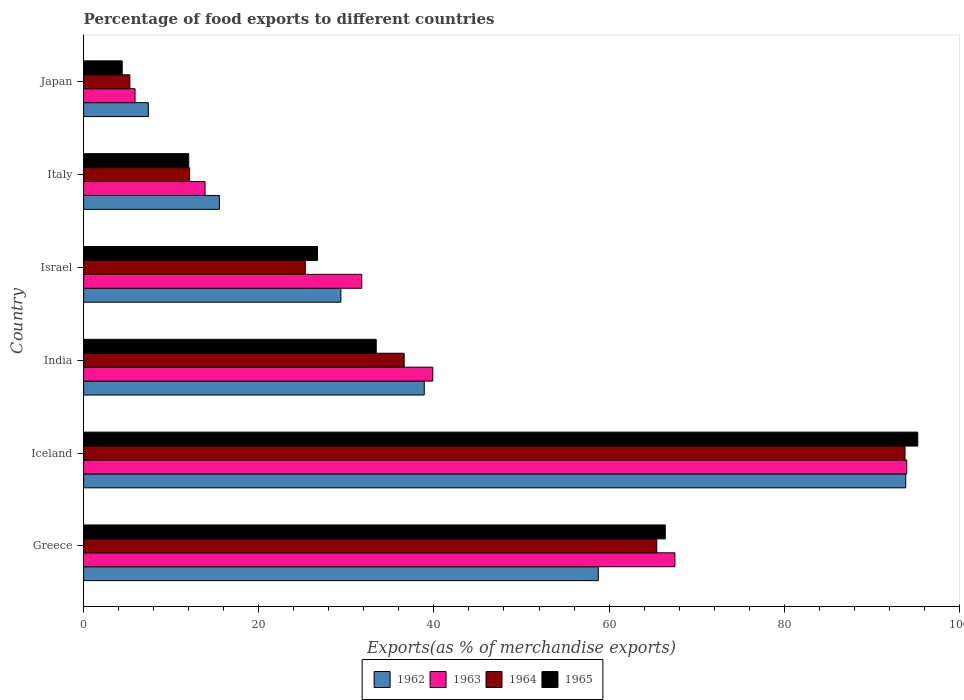How many groups of bars are there?
Keep it short and to the point. 6. Are the number of bars per tick equal to the number of legend labels?
Offer a terse response. Yes. How many bars are there on the 3rd tick from the bottom?
Give a very brief answer. 4. What is the label of the 1st group of bars from the top?
Provide a short and direct response. Japan. In how many cases, is the number of bars for a given country not equal to the number of legend labels?
Offer a terse response. 0. What is the percentage of exports to different countries in 1964 in Greece?
Make the answer very short. 65.45. Across all countries, what is the maximum percentage of exports to different countries in 1964?
Keep it short and to the point. 93.79. Across all countries, what is the minimum percentage of exports to different countries in 1964?
Make the answer very short. 5.28. What is the total percentage of exports to different countries in 1965 in the graph?
Offer a very short reply. 238.2. What is the difference between the percentage of exports to different countries in 1965 in Greece and that in India?
Your answer should be compact. 33.01. What is the difference between the percentage of exports to different countries in 1963 in Greece and the percentage of exports to different countries in 1965 in Iceland?
Ensure brevity in your answer.  -27.73. What is the average percentage of exports to different countries in 1962 per country?
Provide a succinct answer. 40.63. What is the difference between the percentage of exports to different countries in 1964 and percentage of exports to different countries in 1963 in Israel?
Offer a terse response. -6.45. In how many countries, is the percentage of exports to different countries in 1963 greater than 24 %?
Your answer should be compact. 4. What is the ratio of the percentage of exports to different countries in 1965 in Israel to that in Italy?
Provide a short and direct response. 2.23. Is the percentage of exports to different countries in 1965 in Greece less than that in Japan?
Provide a succinct answer. No. What is the difference between the highest and the second highest percentage of exports to different countries in 1962?
Your answer should be compact. 35.1. What is the difference between the highest and the lowest percentage of exports to different countries in 1964?
Provide a succinct answer. 88.51. In how many countries, is the percentage of exports to different countries in 1962 greater than the average percentage of exports to different countries in 1962 taken over all countries?
Give a very brief answer. 2. Is it the case that in every country, the sum of the percentage of exports to different countries in 1962 and percentage of exports to different countries in 1964 is greater than the sum of percentage of exports to different countries in 1963 and percentage of exports to different countries in 1965?
Give a very brief answer. No. How many bars are there?
Provide a short and direct response. 24. Are all the bars in the graph horizontal?
Keep it short and to the point. Yes. What is the difference between two consecutive major ticks on the X-axis?
Your answer should be very brief. 20. Does the graph contain any zero values?
Give a very brief answer. No. Does the graph contain grids?
Provide a succinct answer. No. Where does the legend appear in the graph?
Your answer should be compact. Bottom center. How many legend labels are there?
Ensure brevity in your answer.  4. How are the legend labels stacked?
Give a very brief answer. Horizontal. What is the title of the graph?
Your answer should be very brief. Percentage of food exports to different countries. What is the label or title of the X-axis?
Provide a short and direct response. Exports(as % of merchandise exports). What is the Exports(as % of merchandise exports) of 1962 in Greece?
Offer a terse response. 58.77. What is the Exports(as % of merchandise exports) of 1963 in Greece?
Your answer should be very brief. 67.52. What is the Exports(as % of merchandise exports) in 1964 in Greece?
Make the answer very short. 65.45. What is the Exports(as % of merchandise exports) in 1965 in Greece?
Provide a succinct answer. 66.42. What is the Exports(as % of merchandise exports) in 1962 in Iceland?
Provide a short and direct response. 93.87. What is the Exports(as % of merchandise exports) in 1963 in Iceland?
Give a very brief answer. 93.99. What is the Exports(as % of merchandise exports) in 1964 in Iceland?
Offer a very short reply. 93.79. What is the Exports(as % of merchandise exports) in 1965 in Iceland?
Your answer should be very brief. 95.25. What is the Exports(as % of merchandise exports) of 1962 in India?
Your response must be concise. 38.9. What is the Exports(as % of merchandise exports) in 1963 in India?
Provide a short and direct response. 39.86. What is the Exports(as % of merchandise exports) of 1964 in India?
Your response must be concise. 36.6. What is the Exports(as % of merchandise exports) of 1965 in India?
Make the answer very short. 33.41. What is the Exports(as % of merchandise exports) in 1962 in Israel?
Your response must be concise. 29.37. What is the Exports(as % of merchandise exports) in 1963 in Israel?
Your answer should be compact. 31.76. What is the Exports(as % of merchandise exports) in 1964 in Israel?
Your answer should be compact. 25.31. What is the Exports(as % of merchandise exports) in 1965 in Israel?
Provide a succinct answer. 26.71. What is the Exports(as % of merchandise exports) of 1962 in Italy?
Ensure brevity in your answer.  15.5. What is the Exports(as % of merchandise exports) in 1963 in Italy?
Ensure brevity in your answer.  13.86. What is the Exports(as % of merchandise exports) in 1964 in Italy?
Ensure brevity in your answer.  12.1. What is the Exports(as % of merchandise exports) of 1965 in Italy?
Keep it short and to the point. 12. What is the Exports(as % of merchandise exports) in 1962 in Japan?
Your answer should be compact. 7.39. What is the Exports(as % of merchandise exports) in 1963 in Japan?
Offer a terse response. 5.87. What is the Exports(as % of merchandise exports) of 1964 in Japan?
Keep it short and to the point. 5.28. What is the Exports(as % of merchandise exports) of 1965 in Japan?
Your answer should be very brief. 4.41. Across all countries, what is the maximum Exports(as % of merchandise exports) of 1962?
Make the answer very short. 93.87. Across all countries, what is the maximum Exports(as % of merchandise exports) of 1963?
Offer a terse response. 93.99. Across all countries, what is the maximum Exports(as % of merchandise exports) in 1964?
Provide a short and direct response. 93.79. Across all countries, what is the maximum Exports(as % of merchandise exports) in 1965?
Offer a terse response. 95.25. Across all countries, what is the minimum Exports(as % of merchandise exports) in 1962?
Offer a terse response. 7.39. Across all countries, what is the minimum Exports(as % of merchandise exports) of 1963?
Make the answer very short. 5.87. Across all countries, what is the minimum Exports(as % of merchandise exports) in 1964?
Offer a terse response. 5.28. Across all countries, what is the minimum Exports(as % of merchandise exports) of 1965?
Ensure brevity in your answer.  4.41. What is the total Exports(as % of merchandise exports) in 1962 in the graph?
Make the answer very short. 243.81. What is the total Exports(as % of merchandise exports) of 1963 in the graph?
Your answer should be very brief. 252.87. What is the total Exports(as % of merchandise exports) in 1964 in the graph?
Your answer should be very brief. 238.53. What is the total Exports(as % of merchandise exports) in 1965 in the graph?
Your answer should be compact. 238.2. What is the difference between the Exports(as % of merchandise exports) of 1962 in Greece and that in Iceland?
Ensure brevity in your answer.  -35.1. What is the difference between the Exports(as % of merchandise exports) in 1963 in Greece and that in Iceland?
Keep it short and to the point. -26.47. What is the difference between the Exports(as % of merchandise exports) of 1964 in Greece and that in Iceland?
Keep it short and to the point. -28.35. What is the difference between the Exports(as % of merchandise exports) of 1965 in Greece and that in Iceland?
Provide a succinct answer. -28.83. What is the difference between the Exports(as % of merchandise exports) of 1962 in Greece and that in India?
Make the answer very short. 19.87. What is the difference between the Exports(as % of merchandise exports) in 1963 in Greece and that in India?
Your answer should be very brief. 27.65. What is the difference between the Exports(as % of merchandise exports) of 1964 in Greece and that in India?
Give a very brief answer. 28.84. What is the difference between the Exports(as % of merchandise exports) of 1965 in Greece and that in India?
Keep it short and to the point. 33.01. What is the difference between the Exports(as % of merchandise exports) in 1962 in Greece and that in Israel?
Your answer should be compact. 29.4. What is the difference between the Exports(as % of merchandise exports) of 1963 in Greece and that in Israel?
Keep it short and to the point. 35.76. What is the difference between the Exports(as % of merchandise exports) of 1964 in Greece and that in Israel?
Give a very brief answer. 40.14. What is the difference between the Exports(as % of merchandise exports) of 1965 in Greece and that in Israel?
Ensure brevity in your answer.  39.71. What is the difference between the Exports(as % of merchandise exports) in 1962 in Greece and that in Italy?
Give a very brief answer. 43.27. What is the difference between the Exports(as % of merchandise exports) of 1963 in Greece and that in Italy?
Your answer should be compact. 53.65. What is the difference between the Exports(as % of merchandise exports) of 1964 in Greece and that in Italy?
Provide a succinct answer. 53.35. What is the difference between the Exports(as % of merchandise exports) of 1965 in Greece and that in Italy?
Keep it short and to the point. 54.42. What is the difference between the Exports(as % of merchandise exports) in 1962 in Greece and that in Japan?
Give a very brief answer. 51.38. What is the difference between the Exports(as % of merchandise exports) in 1963 in Greece and that in Japan?
Provide a short and direct response. 61.65. What is the difference between the Exports(as % of merchandise exports) in 1964 in Greece and that in Japan?
Your response must be concise. 60.17. What is the difference between the Exports(as % of merchandise exports) in 1965 in Greece and that in Japan?
Ensure brevity in your answer.  62.01. What is the difference between the Exports(as % of merchandise exports) of 1962 in Iceland and that in India?
Offer a very short reply. 54.98. What is the difference between the Exports(as % of merchandise exports) in 1963 in Iceland and that in India?
Your answer should be compact. 54.13. What is the difference between the Exports(as % of merchandise exports) in 1964 in Iceland and that in India?
Offer a very short reply. 57.19. What is the difference between the Exports(as % of merchandise exports) in 1965 in Iceland and that in India?
Make the answer very short. 61.84. What is the difference between the Exports(as % of merchandise exports) in 1962 in Iceland and that in Israel?
Keep it short and to the point. 64.5. What is the difference between the Exports(as % of merchandise exports) of 1963 in Iceland and that in Israel?
Your response must be concise. 62.23. What is the difference between the Exports(as % of merchandise exports) of 1964 in Iceland and that in Israel?
Your answer should be compact. 68.48. What is the difference between the Exports(as % of merchandise exports) in 1965 in Iceland and that in Israel?
Your answer should be very brief. 68.54. What is the difference between the Exports(as % of merchandise exports) of 1962 in Iceland and that in Italy?
Your response must be concise. 78.37. What is the difference between the Exports(as % of merchandise exports) of 1963 in Iceland and that in Italy?
Keep it short and to the point. 80.13. What is the difference between the Exports(as % of merchandise exports) of 1964 in Iceland and that in Italy?
Offer a very short reply. 81.69. What is the difference between the Exports(as % of merchandise exports) in 1965 in Iceland and that in Italy?
Your answer should be very brief. 83.25. What is the difference between the Exports(as % of merchandise exports) in 1962 in Iceland and that in Japan?
Give a very brief answer. 86.49. What is the difference between the Exports(as % of merchandise exports) of 1963 in Iceland and that in Japan?
Ensure brevity in your answer.  88.12. What is the difference between the Exports(as % of merchandise exports) of 1964 in Iceland and that in Japan?
Provide a short and direct response. 88.51. What is the difference between the Exports(as % of merchandise exports) in 1965 in Iceland and that in Japan?
Your answer should be very brief. 90.84. What is the difference between the Exports(as % of merchandise exports) in 1962 in India and that in Israel?
Your answer should be very brief. 9.52. What is the difference between the Exports(as % of merchandise exports) of 1963 in India and that in Israel?
Make the answer very short. 8.1. What is the difference between the Exports(as % of merchandise exports) in 1964 in India and that in Israel?
Offer a very short reply. 11.29. What is the difference between the Exports(as % of merchandise exports) in 1965 in India and that in Israel?
Keep it short and to the point. 6.71. What is the difference between the Exports(as % of merchandise exports) of 1962 in India and that in Italy?
Your response must be concise. 23.39. What is the difference between the Exports(as % of merchandise exports) in 1963 in India and that in Italy?
Offer a very short reply. 26. What is the difference between the Exports(as % of merchandise exports) of 1964 in India and that in Italy?
Your response must be concise. 24.5. What is the difference between the Exports(as % of merchandise exports) in 1965 in India and that in Italy?
Ensure brevity in your answer.  21.41. What is the difference between the Exports(as % of merchandise exports) of 1962 in India and that in Japan?
Offer a very short reply. 31.51. What is the difference between the Exports(as % of merchandise exports) of 1963 in India and that in Japan?
Provide a succinct answer. 34. What is the difference between the Exports(as % of merchandise exports) of 1964 in India and that in Japan?
Give a very brief answer. 31.32. What is the difference between the Exports(as % of merchandise exports) of 1965 in India and that in Japan?
Provide a short and direct response. 29.01. What is the difference between the Exports(as % of merchandise exports) of 1962 in Israel and that in Italy?
Your answer should be compact. 13.87. What is the difference between the Exports(as % of merchandise exports) in 1963 in Israel and that in Italy?
Keep it short and to the point. 17.9. What is the difference between the Exports(as % of merchandise exports) in 1964 in Israel and that in Italy?
Offer a very short reply. 13.21. What is the difference between the Exports(as % of merchandise exports) in 1965 in Israel and that in Italy?
Your answer should be compact. 14.71. What is the difference between the Exports(as % of merchandise exports) in 1962 in Israel and that in Japan?
Offer a very short reply. 21.98. What is the difference between the Exports(as % of merchandise exports) of 1963 in Israel and that in Japan?
Ensure brevity in your answer.  25.89. What is the difference between the Exports(as % of merchandise exports) in 1964 in Israel and that in Japan?
Offer a very short reply. 20.03. What is the difference between the Exports(as % of merchandise exports) of 1965 in Israel and that in Japan?
Give a very brief answer. 22.3. What is the difference between the Exports(as % of merchandise exports) in 1962 in Italy and that in Japan?
Keep it short and to the point. 8.11. What is the difference between the Exports(as % of merchandise exports) of 1963 in Italy and that in Japan?
Offer a very short reply. 8. What is the difference between the Exports(as % of merchandise exports) in 1964 in Italy and that in Japan?
Your answer should be compact. 6.82. What is the difference between the Exports(as % of merchandise exports) in 1965 in Italy and that in Japan?
Your answer should be compact. 7.59. What is the difference between the Exports(as % of merchandise exports) in 1962 in Greece and the Exports(as % of merchandise exports) in 1963 in Iceland?
Keep it short and to the point. -35.22. What is the difference between the Exports(as % of merchandise exports) of 1962 in Greece and the Exports(as % of merchandise exports) of 1964 in Iceland?
Your answer should be very brief. -35.02. What is the difference between the Exports(as % of merchandise exports) in 1962 in Greece and the Exports(as % of merchandise exports) in 1965 in Iceland?
Give a very brief answer. -36.48. What is the difference between the Exports(as % of merchandise exports) in 1963 in Greece and the Exports(as % of merchandise exports) in 1964 in Iceland?
Ensure brevity in your answer.  -26.27. What is the difference between the Exports(as % of merchandise exports) in 1963 in Greece and the Exports(as % of merchandise exports) in 1965 in Iceland?
Make the answer very short. -27.73. What is the difference between the Exports(as % of merchandise exports) in 1964 in Greece and the Exports(as % of merchandise exports) in 1965 in Iceland?
Provide a short and direct response. -29.8. What is the difference between the Exports(as % of merchandise exports) of 1962 in Greece and the Exports(as % of merchandise exports) of 1963 in India?
Offer a terse response. 18.91. What is the difference between the Exports(as % of merchandise exports) in 1962 in Greece and the Exports(as % of merchandise exports) in 1964 in India?
Offer a terse response. 22.17. What is the difference between the Exports(as % of merchandise exports) in 1962 in Greece and the Exports(as % of merchandise exports) in 1965 in India?
Ensure brevity in your answer.  25.36. What is the difference between the Exports(as % of merchandise exports) in 1963 in Greece and the Exports(as % of merchandise exports) in 1964 in India?
Offer a very short reply. 30.92. What is the difference between the Exports(as % of merchandise exports) of 1963 in Greece and the Exports(as % of merchandise exports) of 1965 in India?
Keep it short and to the point. 34.1. What is the difference between the Exports(as % of merchandise exports) of 1964 in Greece and the Exports(as % of merchandise exports) of 1965 in India?
Make the answer very short. 32.03. What is the difference between the Exports(as % of merchandise exports) of 1962 in Greece and the Exports(as % of merchandise exports) of 1963 in Israel?
Your response must be concise. 27.01. What is the difference between the Exports(as % of merchandise exports) of 1962 in Greece and the Exports(as % of merchandise exports) of 1964 in Israel?
Make the answer very short. 33.46. What is the difference between the Exports(as % of merchandise exports) of 1962 in Greece and the Exports(as % of merchandise exports) of 1965 in Israel?
Make the answer very short. 32.06. What is the difference between the Exports(as % of merchandise exports) in 1963 in Greece and the Exports(as % of merchandise exports) in 1964 in Israel?
Ensure brevity in your answer.  42.21. What is the difference between the Exports(as % of merchandise exports) of 1963 in Greece and the Exports(as % of merchandise exports) of 1965 in Israel?
Your response must be concise. 40.81. What is the difference between the Exports(as % of merchandise exports) of 1964 in Greece and the Exports(as % of merchandise exports) of 1965 in Israel?
Your response must be concise. 38.74. What is the difference between the Exports(as % of merchandise exports) in 1962 in Greece and the Exports(as % of merchandise exports) in 1963 in Italy?
Provide a succinct answer. 44.91. What is the difference between the Exports(as % of merchandise exports) in 1962 in Greece and the Exports(as % of merchandise exports) in 1964 in Italy?
Your response must be concise. 46.67. What is the difference between the Exports(as % of merchandise exports) of 1962 in Greece and the Exports(as % of merchandise exports) of 1965 in Italy?
Your answer should be compact. 46.77. What is the difference between the Exports(as % of merchandise exports) of 1963 in Greece and the Exports(as % of merchandise exports) of 1964 in Italy?
Offer a terse response. 55.42. What is the difference between the Exports(as % of merchandise exports) of 1963 in Greece and the Exports(as % of merchandise exports) of 1965 in Italy?
Keep it short and to the point. 55.52. What is the difference between the Exports(as % of merchandise exports) of 1964 in Greece and the Exports(as % of merchandise exports) of 1965 in Italy?
Offer a terse response. 53.45. What is the difference between the Exports(as % of merchandise exports) in 1962 in Greece and the Exports(as % of merchandise exports) in 1963 in Japan?
Your answer should be very brief. 52.9. What is the difference between the Exports(as % of merchandise exports) in 1962 in Greece and the Exports(as % of merchandise exports) in 1964 in Japan?
Make the answer very short. 53.49. What is the difference between the Exports(as % of merchandise exports) in 1962 in Greece and the Exports(as % of merchandise exports) in 1965 in Japan?
Make the answer very short. 54.36. What is the difference between the Exports(as % of merchandise exports) in 1963 in Greece and the Exports(as % of merchandise exports) in 1964 in Japan?
Keep it short and to the point. 62.24. What is the difference between the Exports(as % of merchandise exports) of 1963 in Greece and the Exports(as % of merchandise exports) of 1965 in Japan?
Provide a short and direct response. 63.11. What is the difference between the Exports(as % of merchandise exports) of 1964 in Greece and the Exports(as % of merchandise exports) of 1965 in Japan?
Provide a short and direct response. 61.04. What is the difference between the Exports(as % of merchandise exports) in 1962 in Iceland and the Exports(as % of merchandise exports) in 1963 in India?
Make the answer very short. 54.01. What is the difference between the Exports(as % of merchandise exports) of 1962 in Iceland and the Exports(as % of merchandise exports) of 1964 in India?
Offer a very short reply. 57.27. What is the difference between the Exports(as % of merchandise exports) in 1962 in Iceland and the Exports(as % of merchandise exports) in 1965 in India?
Provide a succinct answer. 60.46. What is the difference between the Exports(as % of merchandise exports) of 1963 in Iceland and the Exports(as % of merchandise exports) of 1964 in India?
Offer a terse response. 57.39. What is the difference between the Exports(as % of merchandise exports) in 1963 in Iceland and the Exports(as % of merchandise exports) in 1965 in India?
Your response must be concise. 60.58. What is the difference between the Exports(as % of merchandise exports) in 1964 in Iceland and the Exports(as % of merchandise exports) in 1965 in India?
Offer a very short reply. 60.38. What is the difference between the Exports(as % of merchandise exports) of 1962 in Iceland and the Exports(as % of merchandise exports) of 1963 in Israel?
Provide a short and direct response. 62.11. What is the difference between the Exports(as % of merchandise exports) in 1962 in Iceland and the Exports(as % of merchandise exports) in 1964 in Israel?
Offer a very short reply. 68.57. What is the difference between the Exports(as % of merchandise exports) of 1962 in Iceland and the Exports(as % of merchandise exports) of 1965 in Israel?
Ensure brevity in your answer.  67.17. What is the difference between the Exports(as % of merchandise exports) in 1963 in Iceland and the Exports(as % of merchandise exports) in 1964 in Israel?
Offer a very short reply. 68.68. What is the difference between the Exports(as % of merchandise exports) of 1963 in Iceland and the Exports(as % of merchandise exports) of 1965 in Israel?
Your answer should be compact. 67.28. What is the difference between the Exports(as % of merchandise exports) of 1964 in Iceland and the Exports(as % of merchandise exports) of 1965 in Israel?
Offer a terse response. 67.08. What is the difference between the Exports(as % of merchandise exports) in 1962 in Iceland and the Exports(as % of merchandise exports) in 1963 in Italy?
Make the answer very short. 80.01. What is the difference between the Exports(as % of merchandise exports) of 1962 in Iceland and the Exports(as % of merchandise exports) of 1964 in Italy?
Give a very brief answer. 81.78. What is the difference between the Exports(as % of merchandise exports) of 1962 in Iceland and the Exports(as % of merchandise exports) of 1965 in Italy?
Offer a very short reply. 81.88. What is the difference between the Exports(as % of merchandise exports) of 1963 in Iceland and the Exports(as % of merchandise exports) of 1964 in Italy?
Your response must be concise. 81.89. What is the difference between the Exports(as % of merchandise exports) of 1963 in Iceland and the Exports(as % of merchandise exports) of 1965 in Italy?
Keep it short and to the point. 81.99. What is the difference between the Exports(as % of merchandise exports) in 1964 in Iceland and the Exports(as % of merchandise exports) in 1965 in Italy?
Make the answer very short. 81.79. What is the difference between the Exports(as % of merchandise exports) of 1962 in Iceland and the Exports(as % of merchandise exports) of 1963 in Japan?
Offer a very short reply. 88.01. What is the difference between the Exports(as % of merchandise exports) of 1962 in Iceland and the Exports(as % of merchandise exports) of 1964 in Japan?
Keep it short and to the point. 88.6. What is the difference between the Exports(as % of merchandise exports) in 1962 in Iceland and the Exports(as % of merchandise exports) in 1965 in Japan?
Your answer should be compact. 89.47. What is the difference between the Exports(as % of merchandise exports) in 1963 in Iceland and the Exports(as % of merchandise exports) in 1964 in Japan?
Provide a succinct answer. 88.71. What is the difference between the Exports(as % of merchandise exports) in 1963 in Iceland and the Exports(as % of merchandise exports) in 1965 in Japan?
Ensure brevity in your answer.  89.58. What is the difference between the Exports(as % of merchandise exports) of 1964 in Iceland and the Exports(as % of merchandise exports) of 1965 in Japan?
Provide a short and direct response. 89.38. What is the difference between the Exports(as % of merchandise exports) in 1962 in India and the Exports(as % of merchandise exports) in 1963 in Israel?
Ensure brevity in your answer.  7.14. What is the difference between the Exports(as % of merchandise exports) of 1962 in India and the Exports(as % of merchandise exports) of 1964 in Israel?
Your answer should be compact. 13.59. What is the difference between the Exports(as % of merchandise exports) in 1962 in India and the Exports(as % of merchandise exports) in 1965 in Israel?
Your answer should be compact. 12.19. What is the difference between the Exports(as % of merchandise exports) in 1963 in India and the Exports(as % of merchandise exports) in 1964 in Israel?
Ensure brevity in your answer.  14.56. What is the difference between the Exports(as % of merchandise exports) of 1963 in India and the Exports(as % of merchandise exports) of 1965 in Israel?
Your response must be concise. 13.16. What is the difference between the Exports(as % of merchandise exports) in 1964 in India and the Exports(as % of merchandise exports) in 1965 in Israel?
Your response must be concise. 9.89. What is the difference between the Exports(as % of merchandise exports) in 1962 in India and the Exports(as % of merchandise exports) in 1963 in Italy?
Offer a very short reply. 25.03. What is the difference between the Exports(as % of merchandise exports) of 1962 in India and the Exports(as % of merchandise exports) of 1964 in Italy?
Offer a terse response. 26.8. What is the difference between the Exports(as % of merchandise exports) in 1962 in India and the Exports(as % of merchandise exports) in 1965 in Italy?
Your response must be concise. 26.9. What is the difference between the Exports(as % of merchandise exports) in 1963 in India and the Exports(as % of merchandise exports) in 1964 in Italy?
Offer a terse response. 27.77. What is the difference between the Exports(as % of merchandise exports) in 1963 in India and the Exports(as % of merchandise exports) in 1965 in Italy?
Keep it short and to the point. 27.87. What is the difference between the Exports(as % of merchandise exports) in 1964 in India and the Exports(as % of merchandise exports) in 1965 in Italy?
Make the answer very short. 24.6. What is the difference between the Exports(as % of merchandise exports) of 1962 in India and the Exports(as % of merchandise exports) of 1963 in Japan?
Keep it short and to the point. 33.03. What is the difference between the Exports(as % of merchandise exports) of 1962 in India and the Exports(as % of merchandise exports) of 1964 in Japan?
Offer a very short reply. 33.62. What is the difference between the Exports(as % of merchandise exports) of 1962 in India and the Exports(as % of merchandise exports) of 1965 in Japan?
Ensure brevity in your answer.  34.49. What is the difference between the Exports(as % of merchandise exports) of 1963 in India and the Exports(as % of merchandise exports) of 1964 in Japan?
Provide a short and direct response. 34.59. What is the difference between the Exports(as % of merchandise exports) of 1963 in India and the Exports(as % of merchandise exports) of 1965 in Japan?
Make the answer very short. 35.46. What is the difference between the Exports(as % of merchandise exports) in 1964 in India and the Exports(as % of merchandise exports) in 1965 in Japan?
Keep it short and to the point. 32.2. What is the difference between the Exports(as % of merchandise exports) in 1962 in Israel and the Exports(as % of merchandise exports) in 1963 in Italy?
Make the answer very short. 15.51. What is the difference between the Exports(as % of merchandise exports) in 1962 in Israel and the Exports(as % of merchandise exports) in 1964 in Italy?
Provide a short and direct response. 17.27. What is the difference between the Exports(as % of merchandise exports) in 1962 in Israel and the Exports(as % of merchandise exports) in 1965 in Italy?
Make the answer very short. 17.38. What is the difference between the Exports(as % of merchandise exports) in 1963 in Israel and the Exports(as % of merchandise exports) in 1964 in Italy?
Your answer should be compact. 19.66. What is the difference between the Exports(as % of merchandise exports) of 1963 in Israel and the Exports(as % of merchandise exports) of 1965 in Italy?
Offer a terse response. 19.76. What is the difference between the Exports(as % of merchandise exports) in 1964 in Israel and the Exports(as % of merchandise exports) in 1965 in Italy?
Provide a short and direct response. 13.31. What is the difference between the Exports(as % of merchandise exports) of 1962 in Israel and the Exports(as % of merchandise exports) of 1963 in Japan?
Offer a terse response. 23.51. What is the difference between the Exports(as % of merchandise exports) of 1962 in Israel and the Exports(as % of merchandise exports) of 1964 in Japan?
Make the answer very short. 24.1. What is the difference between the Exports(as % of merchandise exports) in 1962 in Israel and the Exports(as % of merchandise exports) in 1965 in Japan?
Offer a terse response. 24.97. What is the difference between the Exports(as % of merchandise exports) in 1963 in Israel and the Exports(as % of merchandise exports) in 1964 in Japan?
Provide a succinct answer. 26.48. What is the difference between the Exports(as % of merchandise exports) in 1963 in Israel and the Exports(as % of merchandise exports) in 1965 in Japan?
Provide a succinct answer. 27.35. What is the difference between the Exports(as % of merchandise exports) of 1964 in Israel and the Exports(as % of merchandise exports) of 1965 in Japan?
Ensure brevity in your answer.  20.9. What is the difference between the Exports(as % of merchandise exports) in 1962 in Italy and the Exports(as % of merchandise exports) in 1963 in Japan?
Your answer should be compact. 9.63. What is the difference between the Exports(as % of merchandise exports) in 1962 in Italy and the Exports(as % of merchandise exports) in 1964 in Japan?
Your answer should be very brief. 10.23. What is the difference between the Exports(as % of merchandise exports) in 1962 in Italy and the Exports(as % of merchandise exports) in 1965 in Japan?
Offer a very short reply. 11.1. What is the difference between the Exports(as % of merchandise exports) in 1963 in Italy and the Exports(as % of merchandise exports) in 1964 in Japan?
Offer a very short reply. 8.59. What is the difference between the Exports(as % of merchandise exports) in 1963 in Italy and the Exports(as % of merchandise exports) in 1965 in Japan?
Make the answer very short. 9.46. What is the difference between the Exports(as % of merchandise exports) of 1964 in Italy and the Exports(as % of merchandise exports) of 1965 in Japan?
Your response must be concise. 7.69. What is the average Exports(as % of merchandise exports) in 1962 per country?
Make the answer very short. 40.63. What is the average Exports(as % of merchandise exports) in 1963 per country?
Keep it short and to the point. 42.14. What is the average Exports(as % of merchandise exports) of 1964 per country?
Provide a succinct answer. 39.75. What is the average Exports(as % of merchandise exports) in 1965 per country?
Make the answer very short. 39.7. What is the difference between the Exports(as % of merchandise exports) of 1962 and Exports(as % of merchandise exports) of 1963 in Greece?
Give a very brief answer. -8.75. What is the difference between the Exports(as % of merchandise exports) of 1962 and Exports(as % of merchandise exports) of 1964 in Greece?
Give a very brief answer. -6.67. What is the difference between the Exports(as % of merchandise exports) of 1962 and Exports(as % of merchandise exports) of 1965 in Greece?
Offer a terse response. -7.65. What is the difference between the Exports(as % of merchandise exports) in 1963 and Exports(as % of merchandise exports) in 1964 in Greece?
Your response must be concise. 2.07. What is the difference between the Exports(as % of merchandise exports) of 1963 and Exports(as % of merchandise exports) of 1965 in Greece?
Offer a terse response. 1.1. What is the difference between the Exports(as % of merchandise exports) of 1964 and Exports(as % of merchandise exports) of 1965 in Greece?
Provide a short and direct response. -0.98. What is the difference between the Exports(as % of merchandise exports) of 1962 and Exports(as % of merchandise exports) of 1963 in Iceland?
Offer a very short reply. -0.12. What is the difference between the Exports(as % of merchandise exports) of 1962 and Exports(as % of merchandise exports) of 1964 in Iceland?
Keep it short and to the point. 0.08. What is the difference between the Exports(as % of merchandise exports) of 1962 and Exports(as % of merchandise exports) of 1965 in Iceland?
Provide a short and direct response. -1.38. What is the difference between the Exports(as % of merchandise exports) in 1963 and Exports(as % of merchandise exports) in 1964 in Iceland?
Give a very brief answer. 0.2. What is the difference between the Exports(as % of merchandise exports) of 1963 and Exports(as % of merchandise exports) of 1965 in Iceland?
Your answer should be very brief. -1.26. What is the difference between the Exports(as % of merchandise exports) in 1964 and Exports(as % of merchandise exports) in 1965 in Iceland?
Offer a very short reply. -1.46. What is the difference between the Exports(as % of merchandise exports) of 1962 and Exports(as % of merchandise exports) of 1963 in India?
Your response must be concise. -0.97. What is the difference between the Exports(as % of merchandise exports) of 1962 and Exports(as % of merchandise exports) of 1964 in India?
Provide a succinct answer. 2.29. What is the difference between the Exports(as % of merchandise exports) of 1962 and Exports(as % of merchandise exports) of 1965 in India?
Offer a very short reply. 5.48. What is the difference between the Exports(as % of merchandise exports) of 1963 and Exports(as % of merchandise exports) of 1964 in India?
Make the answer very short. 3.26. What is the difference between the Exports(as % of merchandise exports) of 1963 and Exports(as % of merchandise exports) of 1965 in India?
Offer a very short reply. 6.45. What is the difference between the Exports(as % of merchandise exports) of 1964 and Exports(as % of merchandise exports) of 1965 in India?
Your response must be concise. 3.19. What is the difference between the Exports(as % of merchandise exports) of 1962 and Exports(as % of merchandise exports) of 1963 in Israel?
Give a very brief answer. -2.39. What is the difference between the Exports(as % of merchandise exports) in 1962 and Exports(as % of merchandise exports) in 1964 in Israel?
Keep it short and to the point. 4.07. What is the difference between the Exports(as % of merchandise exports) of 1962 and Exports(as % of merchandise exports) of 1965 in Israel?
Give a very brief answer. 2.67. What is the difference between the Exports(as % of merchandise exports) in 1963 and Exports(as % of merchandise exports) in 1964 in Israel?
Keep it short and to the point. 6.45. What is the difference between the Exports(as % of merchandise exports) of 1963 and Exports(as % of merchandise exports) of 1965 in Israel?
Make the answer very short. 5.05. What is the difference between the Exports(as % of merchandise exports) in 1964 and Exports(as % of merchandise exports) in 1965 in Israel?
Give a very brief answer. -1.4. What is the difference between the Exports(as % of merchandise exports) in 1962 and Exports(as % of merchandise exports) in 1963 in Italy?
Your response must be concise. 1.64. What is the difference between the Exports(as % of merchandise exports) of 1962 and Exports(as % of merchandise exports) of 1964 in Italy?
Your answer should be compact. 3.4. What is the difference between the Exports(as % of merchandise exports) in 1962 and Exports(as % of merchandise exports) in 1965 in Italy?
Your response must be concise. 3.5. What is the difference between the Exports(as % of merchandise exports) of 1963 and Exports(as % of merchandise exports) of 1964 in Italy?
Provide a short and direct response. 1.77. What is the difference between the Exports(as % of merchandise exports) in 1963 and Exports(as % of merchandise exports) in 1965 in Italy?
Offer a terse response. 1.87. What is the difference between the Exports(as % of merchandise exports) in 1964 and Exports(as % of merchandise exports) in 1965 in Italy?
Provide a succinct answer. 0.1. What is the difference between the Exports(as % of merchandise exports) in 1962 and Exports(as % of merchandise exports) in 1963 in Japan?
Give a very brief answer. 1.52. What is the difference between the Exports(as % of merchandise exports) of 1962 and Exports(as % of merchandise exports) of 1964 in Japan?
Your response must be concise. 2.11. What is the difference between the Exports(as % of merchandise exports) in 1962 and Exports(as % of merchandise exports) in 1965 in Japan?
Your answer should be very brief. 2.98. What is the difference between the Exports(as % of merchandise exports) of 1963 and Exports(as % of merchandise exports) of 1964 in Japan?
Offer a very short reply. 0.59. What is the difference between the Exports(as % of merchandise exports) in 1963 and Exports(as % of merchandise exports) in 1965 in Japan?
Give a very brief answer. 1.46. What is the difference between the Exports(as % of merchandise exports) in 1964 and Exports(as % of merchandise exports) in 1965 in Japan?
Give a very brief answer. 0.87. What is the ratio of the Exports(as % of merchandise exports) in 1962 in Greece to that in Iceland?
Offer a terse response. 0.63. What is the ratio of the Exports(as % of merchandise exports) in 1963 in Greece to that in Iceland?
Give a very brief answer. 0.72. What is the ratio of the Exports(as % of merchandise exports) of 1964 in Greece to that in Iceland?
Provide a short and direct response. 0.7. What is the ratio of the Exports(as % of merchandise exports) in 1965 in Greece to that in Iceland?
Offer a terse response. 0.7. What is the ratio of the Exports(as % of merchandise exports) of 1962 in Greece to that in India?
Offer a terse response. 1.51. What is the ratio of the Exports(as % of merchandise exports) in 1963 in Greece to that in India?
Offer a very short reply. 1.69. What is the ratio of the Exports(as % of merchandise exports) in 1964 in Greece to that in India?
Keep it short and to the point. 1.79. What is the ratio of the Exports(as % of merchandise exports) in 1965 in Greece to that in India?
Your response must be concise. 1.99. What is the ratio of the Exports(as % of merchandise exports) in 1962 in Greece to that in Israel?
Make the answer very short. 2. What is the ratio of the Exports(as % of merchandise exports) in 1963 in Greece to that in Israel?
Your answer should be very brief. 2.13. What is the ratio of the Exports(as % of merchandise exports) in 1964 in Greece to that in Israel?
Ensure brevity in your answer.  2.59. What is the ratio of the Exports(as % of merchandise exports) of 1965 in Greece to that in Israel?
Ensure brevity in your answer.  2.49. What is the ratio of the Exports(as % of merchandise exports) of 1962 in Greece to that in Italy?
Your answer should be very brief. 3.79. What is the ratio of the Exports(as % of merchandise exports) of 1963 in Greece to that in Italy?
Give a very brief answer. 4.87. What is the ratio of the Exports(as % of merchandise exports) of 1964 in Greece to that in Italy?
Your answer should be compact. 5.41. What is the ratio of the Exports(as % of merchandise exports) of 1965 in Greece to that in Italy?
Give a very brief answer. 5.54. What is the ratio of the Exports(as % of merchandise exports) of 1962 in Greece to that in Japan?
Give a very brief answer. 7.95. What is the ratio of the Exports(as % of merchandise exports) of 1963 in Greece to that in Japan?
Ensure brevity in your answer.  11.5. What is the ratio of the Exports(as % of merchandise exports) in 1964 in Greece to that in Japan?
Offer a terse response. 12.4. What is the ratio of the Exports(as % of merchandise exports) in 1965 in Greece to that in Japan?
Your answer should be compact. 15.07. What is the ratio of the Exports(as % of merchandise exports) of 1962 in Iceland to that in India?
Keep it short and to the point. 2.41. What is the ratio of the Exports(as % of merchandise exports) in 1963 in Iceland to that in India?
Your response must be concise. 2.36. What is the ratio of the Exports(as % of merchandise exports) in 1964 in Iceland to that in India?
Keep it short and to the point. 2.56. What is the ratio of the Exports(as % of merchandise exports) in 1965 in Iceland to that in India?
Keep it short and to the point. 2.85. What is the ratio of the Exports(as % of merchandise exports) of 1962 in Iceland to that in Israel?
Keep it short and to the point. 3.2. What is the ratio of the Exports(as % of merchandise exports) of 1963 in Iceland to that in Israel?
Your answer should be compact. 2.96. What is the ratio of the Exports(as % of merchandise exports) of 1964 in Iceland to that in Israel?
Make the answer very short. 3.71. What is the ratio of the Exports(as % of merchandise exports) in 1965 in Iceland to that in Israel?
Make the answer very short. 3.57. What is the ratio of the Exports(as % of merchandise exports) of 1962 in Iceland to that in Italy?
Keep it short and to the point. 6.05. What is the ratio of the Exports(as % of merchandise exports) in 1963 in Iceland to that in Italy?
Give a very brief answer. 6.78. What is the ratio of the Exports(as % of merchandise exports) in 1964 in Iceland to that in Italy?
Give a very brief answer. 7.75. What is the ratio of the Exports(as % of merchandise exports) in 1965 in Iceland to that in Italy?
Keep it short and to the point. 7.94. What is the ratio of the Exports(as % of merchandise exports) of 1962 in Iceland to that in Japan?
Your answer should be very brief. 12.7. What is the ratio of the Exports(as % of merchandise exports) in 1963 in Iceland to that in Japan?
Keep it short and to the point. 16.01. What is the ratio of the Exports(as % of merchandise exports) of 1964 in Iceland to that in Japan?
Provide a short and direct response. 17.77. What is the ratio of the Exports(as % of merchandise exports) of 1965 in Iceland to that in Japan?
Your response must be concise. 21.62. What is the ratio of the Exports(as % of merchandise exports) of 1962 in India to that in Israel?
Provide a short and direct response. 1.32. What is the ratio of the Exports(as % of merchandise exports) in 1963 in India to that in Israel?
Your response must be concise. 1.26. What is the ratio of the Exports(as % of merchandise exports) in 1964 in India to that in Israel?
Your response must be concise. 1.45. What is the ratio of the Exports(as % of merchandise exports) of 1965 in India to that in Israel?
Your response must be concise. 1.25. What is the ratio of the Exports(as % of merchandise exports) of 1962 in India to that in Italy?
Your response must be concise. 2.51. What is the ratio of the Exports(as % of merchandise exports) of 1963 in India to that in Italy?
Your answer should be compact. 2.88. What is the ratio of the Exports(as % of merchandise exports) of 1964 in India to that in Italy?
Offer a very short reply. 3.03. What is the ratio of the Exports(as % of merchandise exports) of 1965 in India to that in Italy?
Give a very brief answer. 2.78. What is the ratio of the Exports(as % of merchandise exports) in 1962 in India to that in Japan?
Provide a succinct answer. 5.26. What is the ratio of the Exports(as % of merchandise exports) of 1963 in India to that in Japan?
Your answer should be very brief. 6.79. What is the ratio of the Exports(as % of merchandise exports) of 1964 in India to that in Japan?
Keep it short and to the point. 6.93. What is the ratio of the Exports(as % of merchandise exports) in 1965 in India to that in Japan?
Keep it short and to the point. 7.58. What is the ratio of the Exports(as % of merchandise exports) of 1962 in Israel to that in Italy?
Your answer should be compact. 1.89. What is the ratio of the Exports(as % of merchandise exports) of 1963 in Israel to that in Italy?
Your answer should be very brief. 2.29. What is the ratio of the Exports(as % of merchandise exports) in 1964 in Israel to that in Italy?
Offer a terse response. 2.09. What is the ratio of the Exports(as % of merchandise exports) of 1965 in Israel to that in Italy?
Your response must be concise. 2.23. What is the ratio of the Exports(as % of merchandise exports) in 1962 in Israel to that in Japan?
Provide a short and direct response. 3.98. What is the ratio of the Exports(as % of merchandise exports) in 1963 in Israel to that in Japan?
Your response must be concise. 5.41. What is the ratio of the Exports(as % of merchandise exports) in 1964 in Israel to that in Japan?
Your answer should be very brief. 4.79. What is the ratio of the Exports(as % of merchandise exports) in 1965 in Israel to that in Japan?
Your answer should be very brief. 6.06. What is the ratio of the Exports(as % of merchandise exports) of 1962 in Italy to that in Japan?
Your response must be concise. 2.1. What is the ratio of the Exports(as % of merchandise exports) in 1963 in Italy to that in Japan?
Ensure brevity in your answer.  2.36. What is the ratio of the Exports(as % of merchandise exports) in 1964 in Italy to that in Japan?
Your answer should be compact. 2.29. What is the ratio of the Exports(as % of merchandise exports) of 1965 in Italy to that in Japan?
Your response must be concise. 2.72. What is the difference between the highest and the second highest Exports(as % of merchandise exports) in 1962?
Ensure brevity in your answer.  35.1. What is the difference between the highest and the second highest Exports(as % of merchandise exports) of 1963?
Your response must be concise. 26.47. What is the difference between the highest and the second highest Exports(as % of merchandise exports) of 1964?
Your answer should be very brief. 28.35. What is the difference between the highest and the second highest Exports(as % of merchandise exports) in 1965?
Provide a short and direct response. 28.83. What is the difference between the highest and the lowest Exports(as % of merchandise exports) in 1962?
Your response must be concise. 86.49. What is the difference between the highest and the lowest Exports(as % of merchandise exports) of 1963?
Make the answer very short. 88.12. What is the difference between the highest and the lowest Exports(as % of merchandise exports) in 1964?
Make the answer very short. 88.51. What is the difference between the highest and the lowest Exports(as % of merchandise exports) in 1965?
Your answer should be very brief. 90.84. 